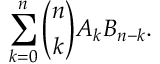Convert formula to latex. <formula><loc_0><loc_0><loc_500><loc_500>\sum _ { k = 0 } ^ { n } { \binom { n } { k } } A _ { k } B _ { n - k } .</formula> 